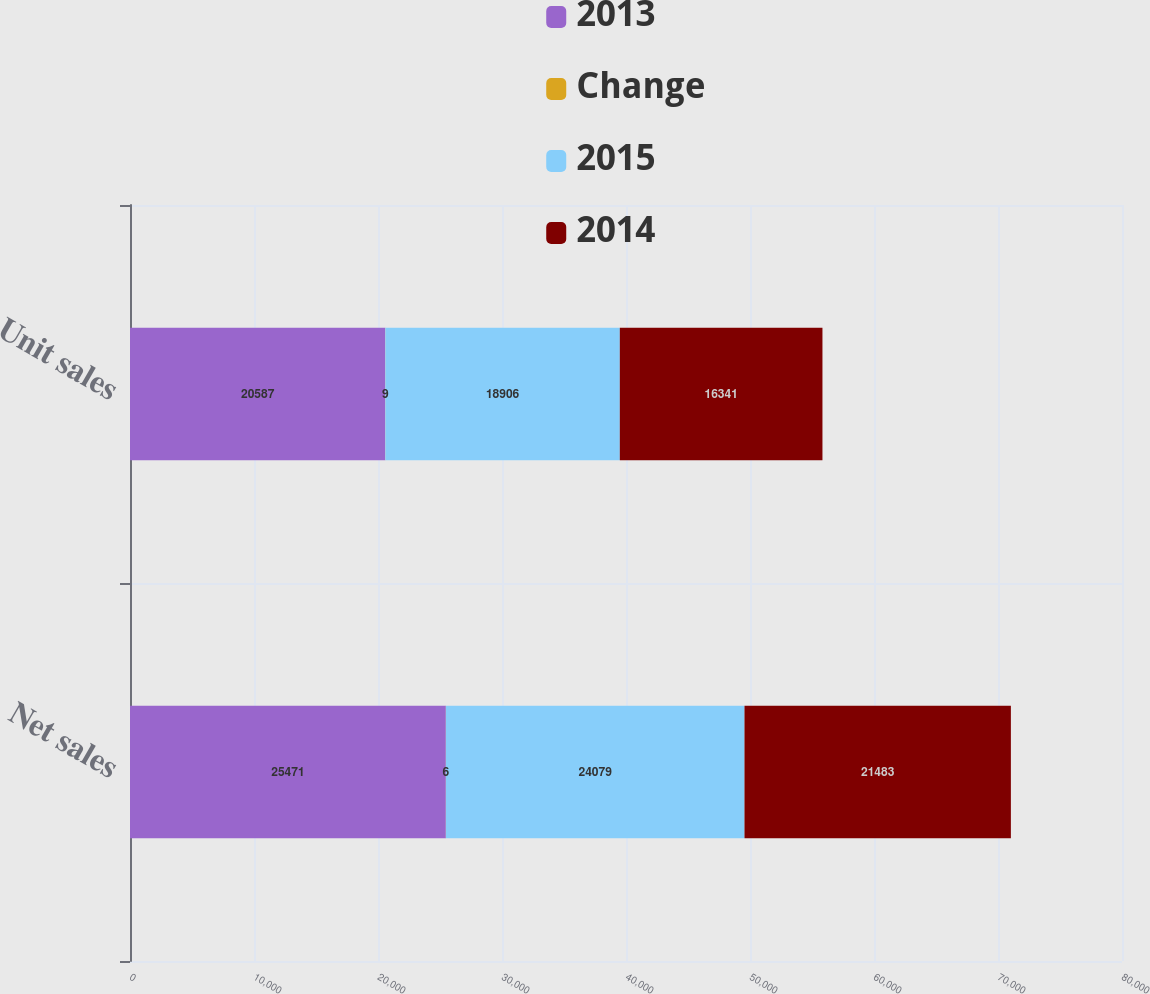Convert chart. <chart><loc_0><loc_0><loc_500><loc_500><stacked_bar_chart><ecel><fcel>Net sales<fcel>Unit sales<nl><fcel>2013<fcel>25471<fcel>20587<nl><fcel>Change<fcel>6<fcel>9<nl><fcel>2015<fcel>24079<fcel>18906<nl><fcel>2014<fcel>21483<fcel>16341<nl></chart> 